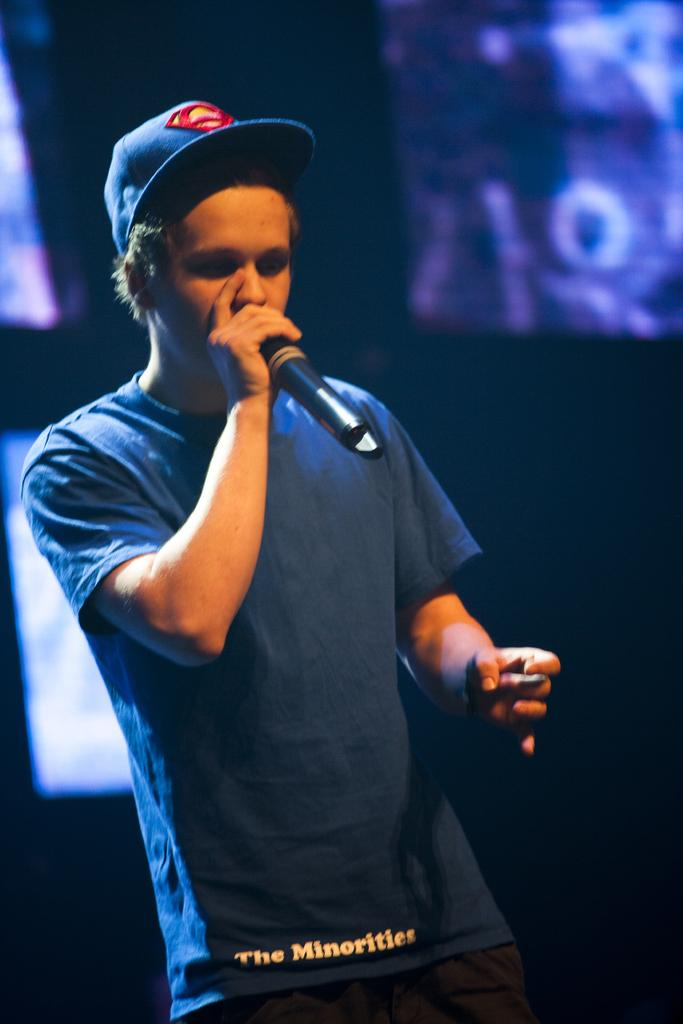Who is present in the image? There is a man in the image. What is the man wearing on his upper body? The man is wearing a blue t-shirt. What type of headwear is the man wearing? The man is wearing a cap. What is the man holding in his hand? The man is holding a mic. What can be seen in the background of the image? There are screens in the background of the image. How would you describe the lighting in the image? The image is slightly dark. Can you see any corks in the image? There are no corks present in the image. Are there any fangs visible on the man in the image? There are no fangs visible on the man in the image. 